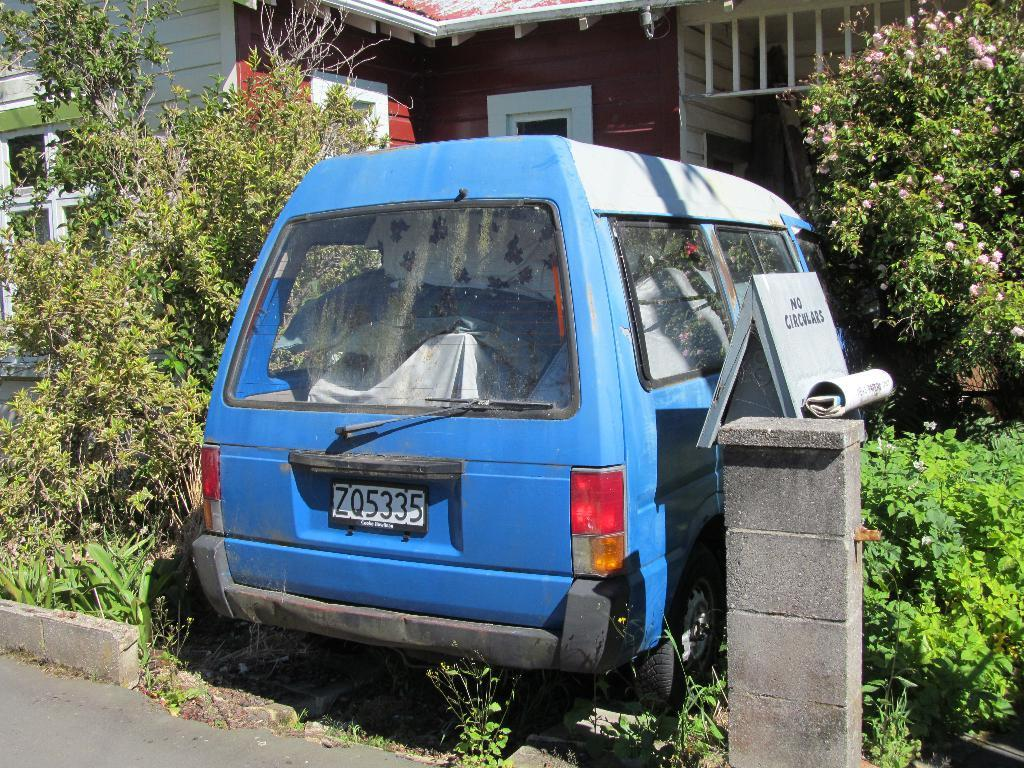Provide a one-sentence caption for the provided image. A blue van with the license plate ZQ5335 sets in an overgrown driveway. 